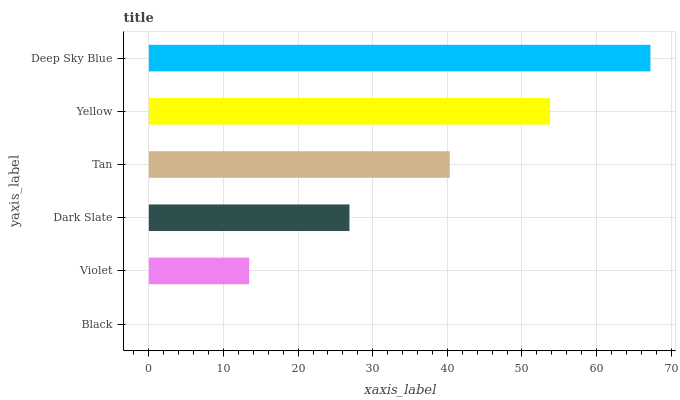Is Black the minimum?
Answer yes or no. Yes. Is Deep Sky Blue the maximum?
Answer yes or no. Yes. Is Violet the minimum?
Answer yes or no. No. Is Violet the maximum?
Answer yes or no. No. Is Violet greater than Black?
Answer yes or no. Yes. Is Black less than Violet?
Answer yes or no. Yes. Is Black greater than Violet?
Answer yes or no. No. Is Violet less than Black?
Answer yes or no. No. Is Tan the high median?
Answer yes or no. Yes. Is Dark Slate the low median?
Answer yes or no. Yes. Is Dark Slate the high median?
Answer yes or no. No. Is Deep Sky Blue the low median?
Answer yes or no. No. 